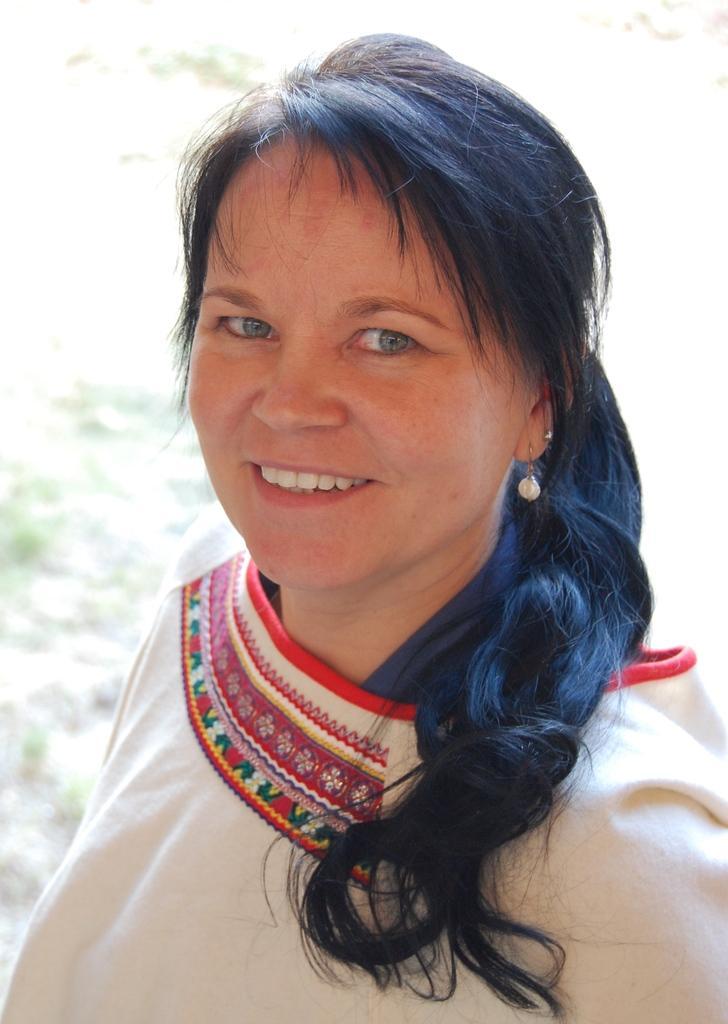Describe this image in one or two sentences. Here we can see a woman is smiling. In the background the image is not clear. 